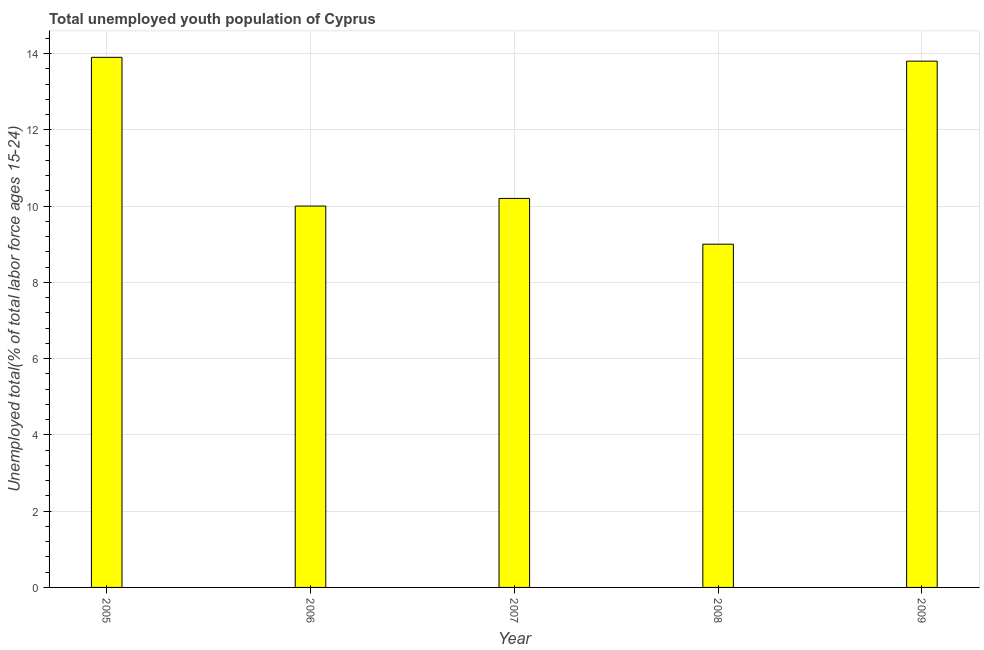What is the title of the graph?
Provide a short and direct response. Total unemployed youth population of Cyprus. What is the label or title of the Y-axis?
Give a very brief answer. Unemployed total(% of total labor force ages 15-24). What is the unemployed youth in 2009?
Offer a very short reply. 13.8. Across all years, what is the maximum unemployed youth?
Keep it short and to the point. 13.9. What is the sum of the unemployed youth?
Your answer should be compact. 56.9. What is the average unemployed youth per year?
Ensure brevity in your answer.  11.38. What is the median unemployed youth?
Provide a succinct answer. 10.2. What is the ratio of the unemployed youth in 2007 to that in 2008?
Your response must be concise. 1.13. Is the difference between the unemployed youth in 2006 and 2007 greater than the difference between any two years?
Provide a short and direct response. No. Is the sum of the unemployed youth in 2006 and 2009 greater than the maximum unemployed youth across all years?
Offer a terse response. Yes. What is the difference between the highest and the lowest unemployed youth?
Your answer should be very brief. 4.9. How many bars are there?
Offer a terse response. 5. Are all the bars in the graph horizontal?
Make the answer very short. No. What is the difference between two consecutive major ticks on the Y-axis?
Your response must be concise. 2. What is the Unemployed total(% of total labor force ages 15-24) of 2005?
Ensure brevity in your answer.  13.9. What is the Unemployed total(% of total labor force ages 15-24) in 2006?
Make the answer very short. 10. What is the Unemployed total(% of total labor force ages 15-24) of 2007?
Give a very brief answer. 10.2. What is the Unemployed total(% of total labor force ages 15-24) in 2009?
Your response must be concise. 13.8. What is the difference between the Unemployed total(% of total labor force ages 15-24) in 2005 and 2006?
Give a very brief answer. 3.9. What is the difference between the Unemployed total(% of total labor force ages 15-24) in 2005 and 2009?
Make the answer very short. 0.1. What is the difference between the Unemployed total(% of total labor force ages 15-24) in 2006 and 2007?
Provide a short and direct response. -0.2. What is the difference between the Unemployed total(% of total labor force ages 15-24) in 2006 and 2009?
Provide a short and direct response. -3.8. What is the difference between the Unemployed total(% of total labor force ages 15-24) in 2007 and 2008?
Ensure brevity in your answer.  1.2. What is the difference between the Unemployed total(% of total labor force ages 15-24) in 2007 and 2009?
Keep it short and to the point. -3.6. What is the ratio of the Unemployed total(% of total labor force ages 15-24) in 2005 to that in 2006?
Offer a terse response. 1.39. What is the ratio of the Unemployed total(% of total labor force ages 15-24) in 2005 to that in 2007?
Give a very brief answer. 1.36. What is the ratio of the Unemployed total(% of total labor force ages 15-24) in 2005 to that in 2008?
Give a very brief answer. 1.54. What is the ratio of the Unemployed total(% of total labor force ages 15-24) in 2006 to that in 2007?
Your answer should be very brief. 0.98. What is the ratio of the Unemployed total(% of total labor force ages 15-24) in 2006 to that in 2008?
Ensure brevity in your answer.  1.11. What is the ratio of the Unemployed total(% of total labor force ages 15-24) in 2006 to that in 2009?
Provide a short and direct response. 0.72. What is the ratio of the Unemployed total(% of total labor force ages 15-24) in 2007 to that in 2008?
Give a very brief answer. 1.13. What is the ratio of the Unemployed total(% of total labor force ages 15-24) in 2007 to that in 2009?
Your answer should be very brief. 0.74. What is the ratio of the Unemployed total(% of total labor force ages 15-24) in 2008 to that in 2009?
Provide a short and direct response. 0.65. 